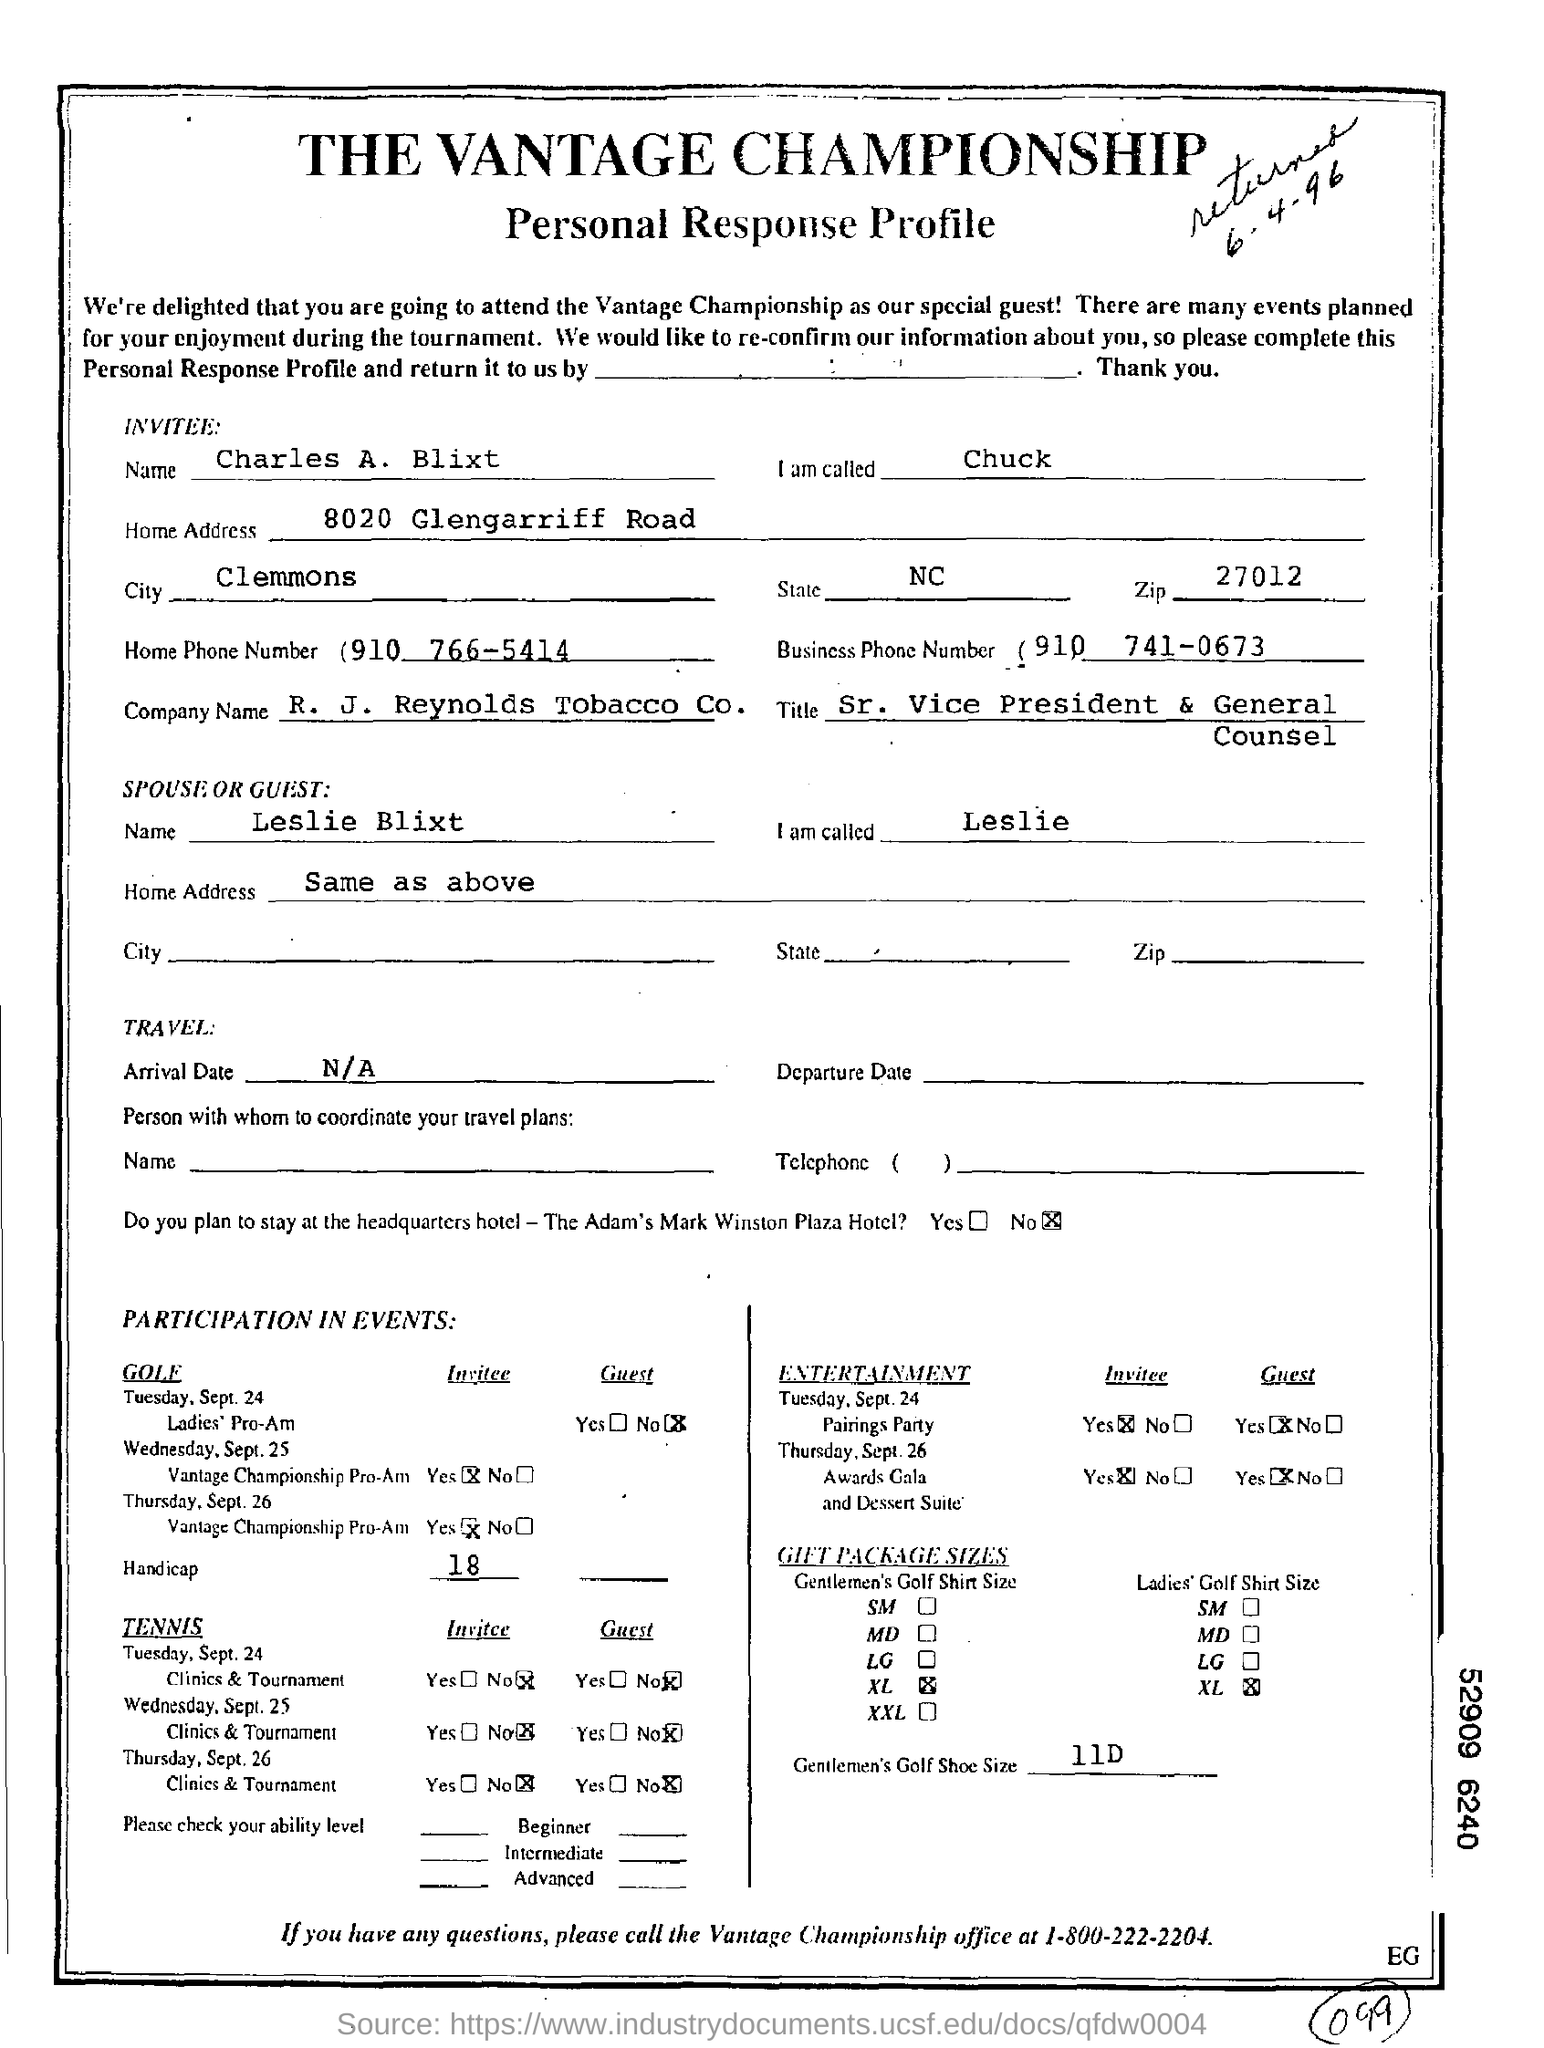Who's Personal Response Profile is given here?
Provide a short and direct response. Charles A. Blixt. In which city, does Charles A. Blixt belongs to?
Provide a short and direct response. Clemmons. In which company,  does Charles A. Blixt works?
Your answer should be very brief. R.  J.  Reynolds Tobacco Co. What is the job title of Charles A. Blixt?
Your answer should be very brief. Sr. Vice President & General Counsel. What is the Zip code as mentioned in the profile?
Offer a terse response. 27012. 